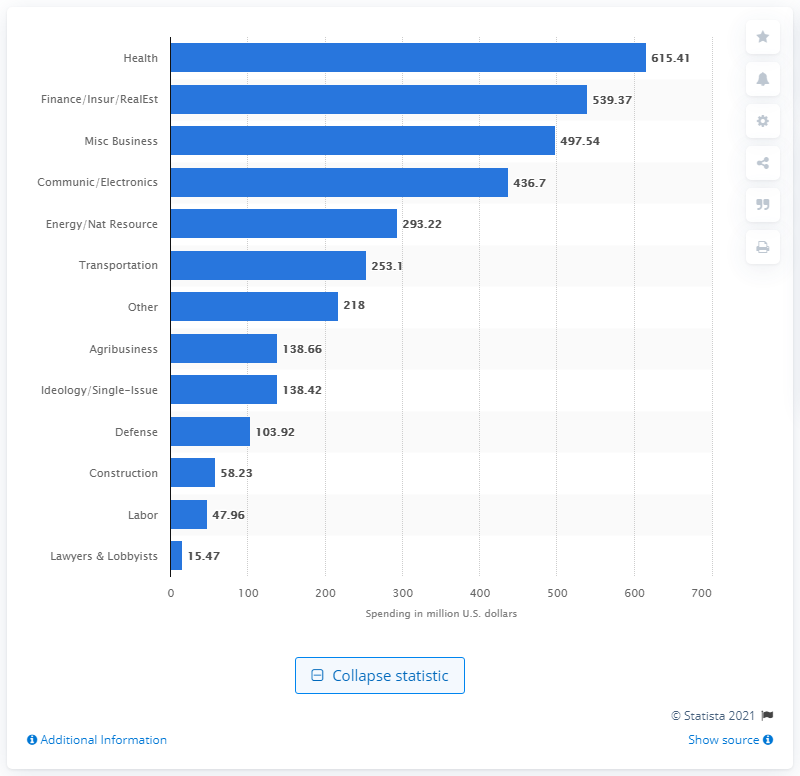Highlight a few significant elements in this photo. In 2020, approximately $138.66 million was spent on lobbying in the agribusiness sector. 